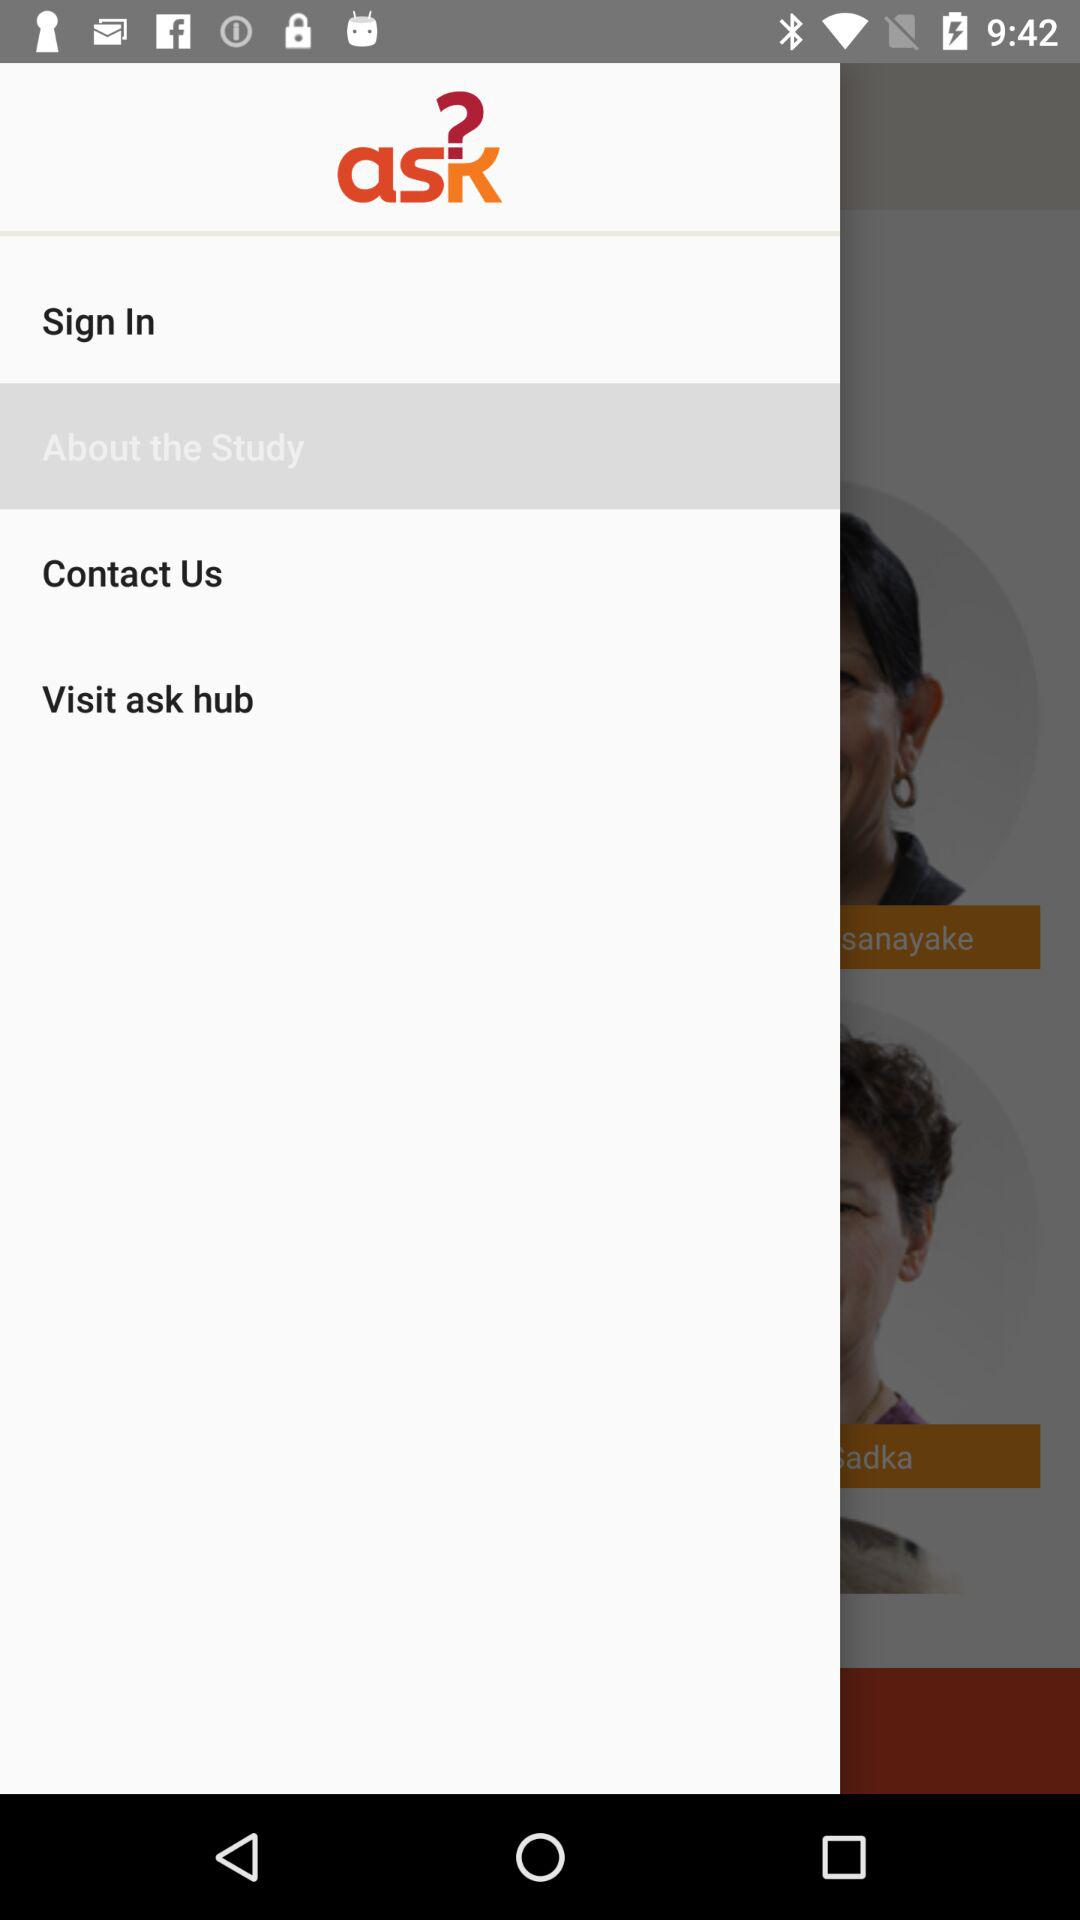What is the selected item? The selected item is "About the Study". 